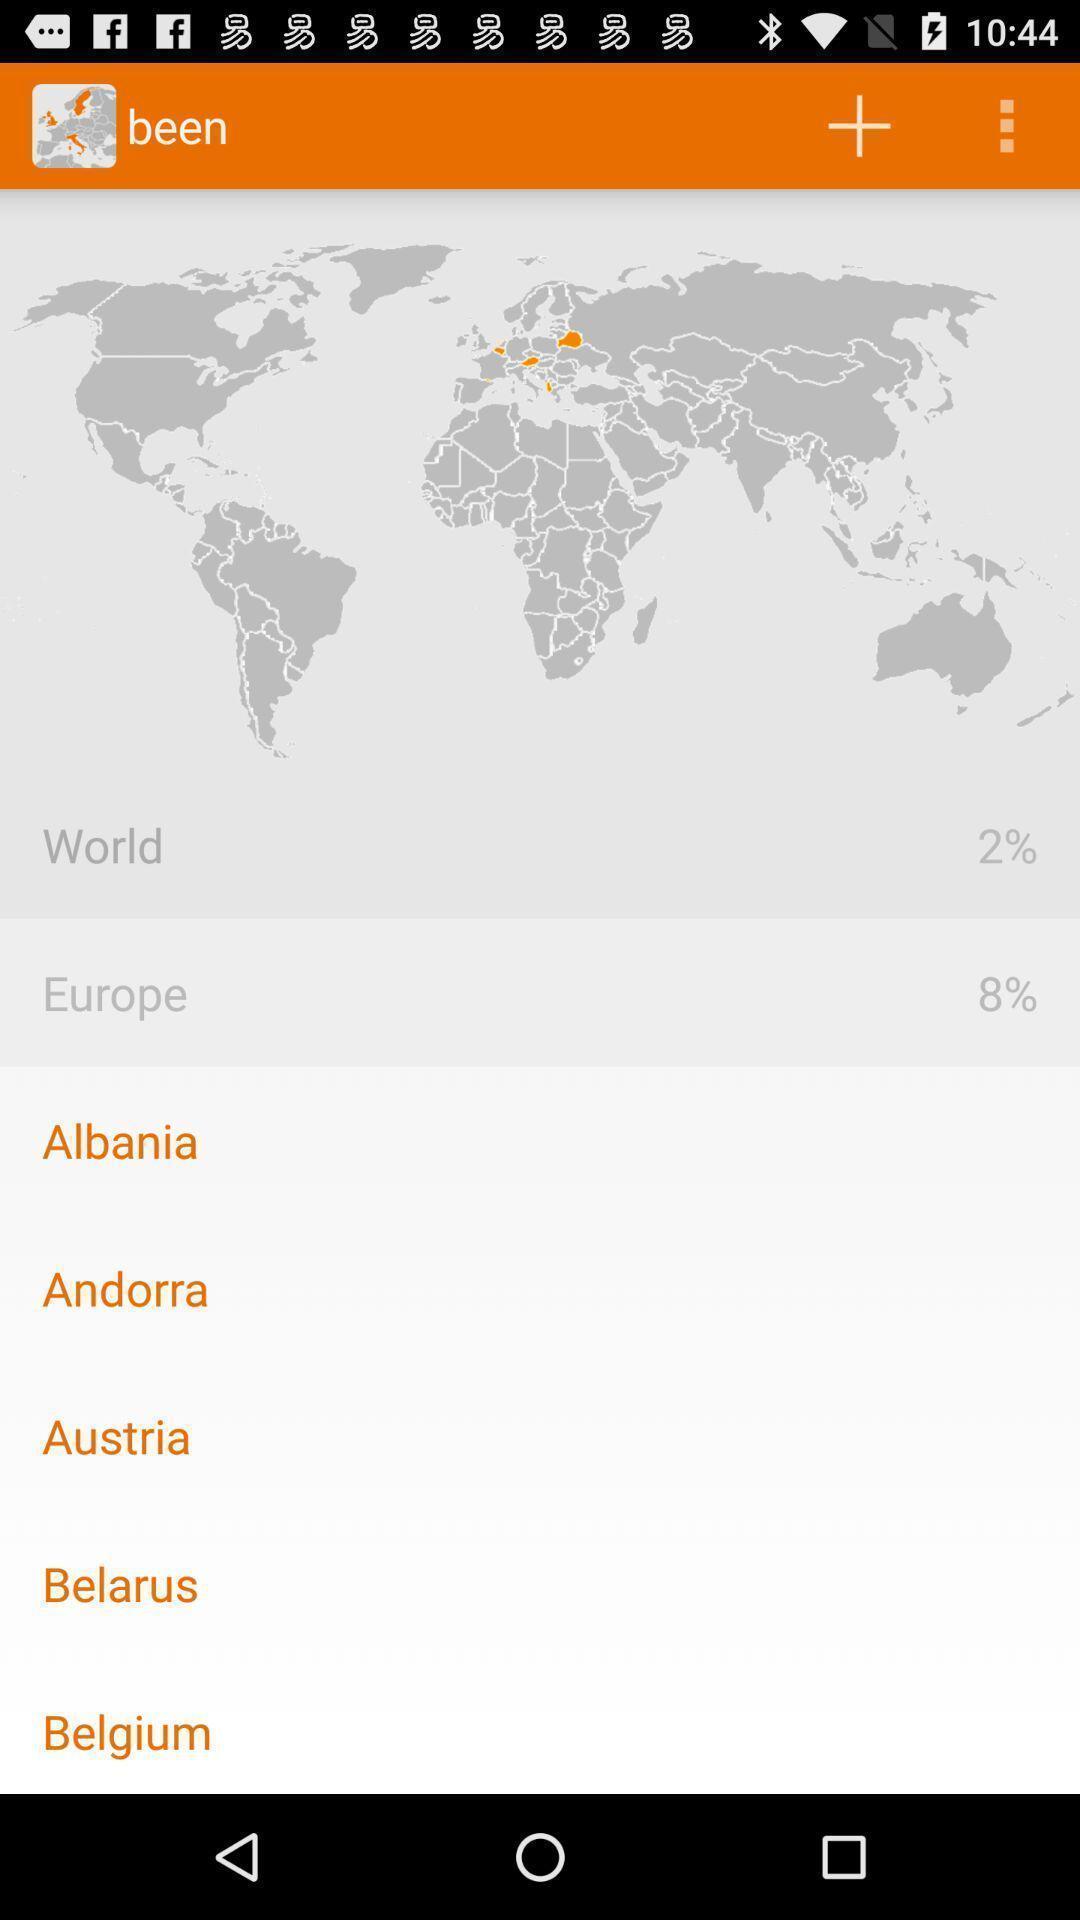Summarize the information in this screenshot. Screen showing list of various cities. 